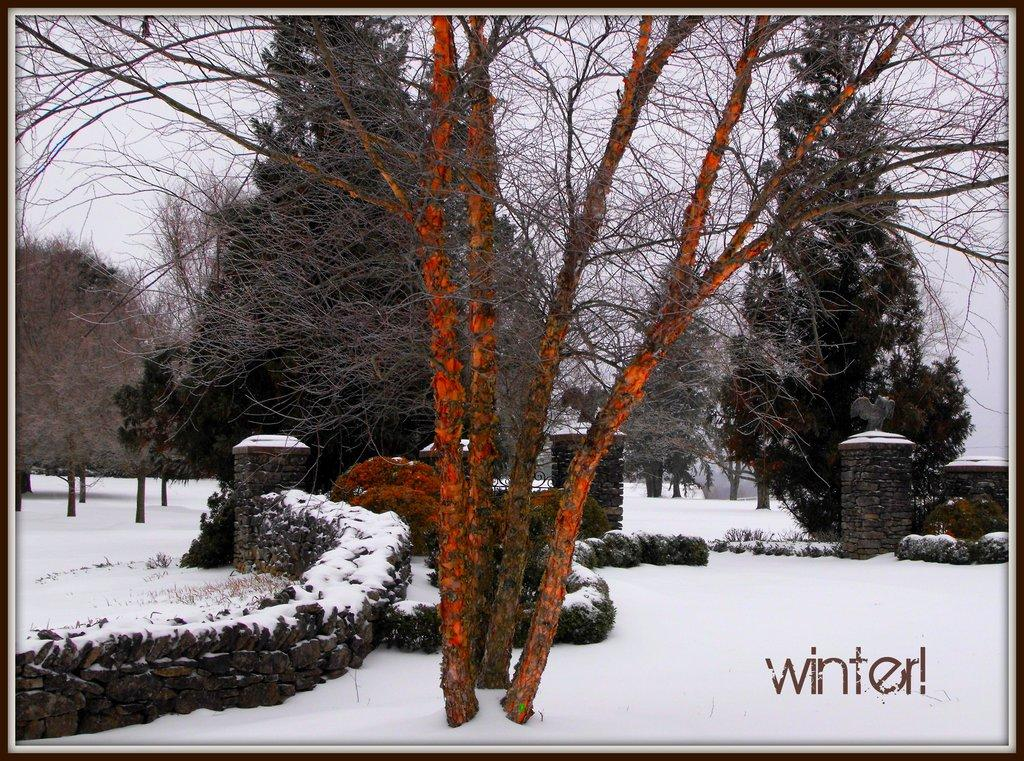What type of natural environment is depicted in the image? The image features many trees, suggesting a forest or wooded area. What is the weather like in the image? There is snow visible in the image, indicating a cold or wintery environment. What type of structure can be seen in the image? There is a wall in the image, which could be part of a building or fence. What is visible in the background of the image? The sky is visible in the image, providing context for the weather and time of day. Where is the mailbox located in the image? There is no mailbox present in the image. What type of government is depicted in the image? The image does not depict any form of government or political system. 